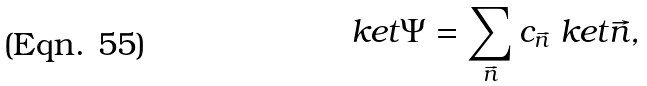Convert formula to latex. <formula><loc_0><loc_0><loc_500><loc_500>\ k e t { \Psi } = \sum _ { \vec { n } } c _ { \vec { n } } \ k e t { \vec { n } } ,</formula> 